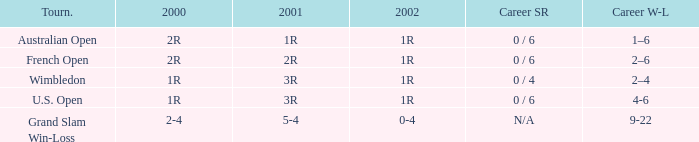In what year 2000 tournment did Angeles Montolio have a career win-loss record of 2-4? Grand Slam Win-Loss. 